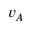<formula> <loc_0><loc_0><loc_500><loc_500>v _ { A }</formula> 